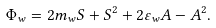Convert formula to latex. <formula><loc_0><loc_0><loc_500><loc_500>\Phi _ { w } = 2 m _ { w } S + S ^ { 2 } + 2 \varepsilon _ { w } A - A ^ { 2 } .</formula> 